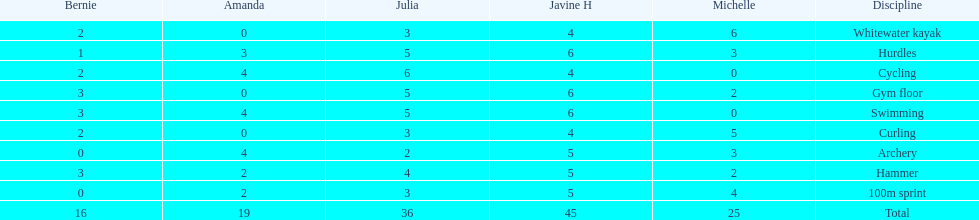Who had her best score in cycling? Julia. 